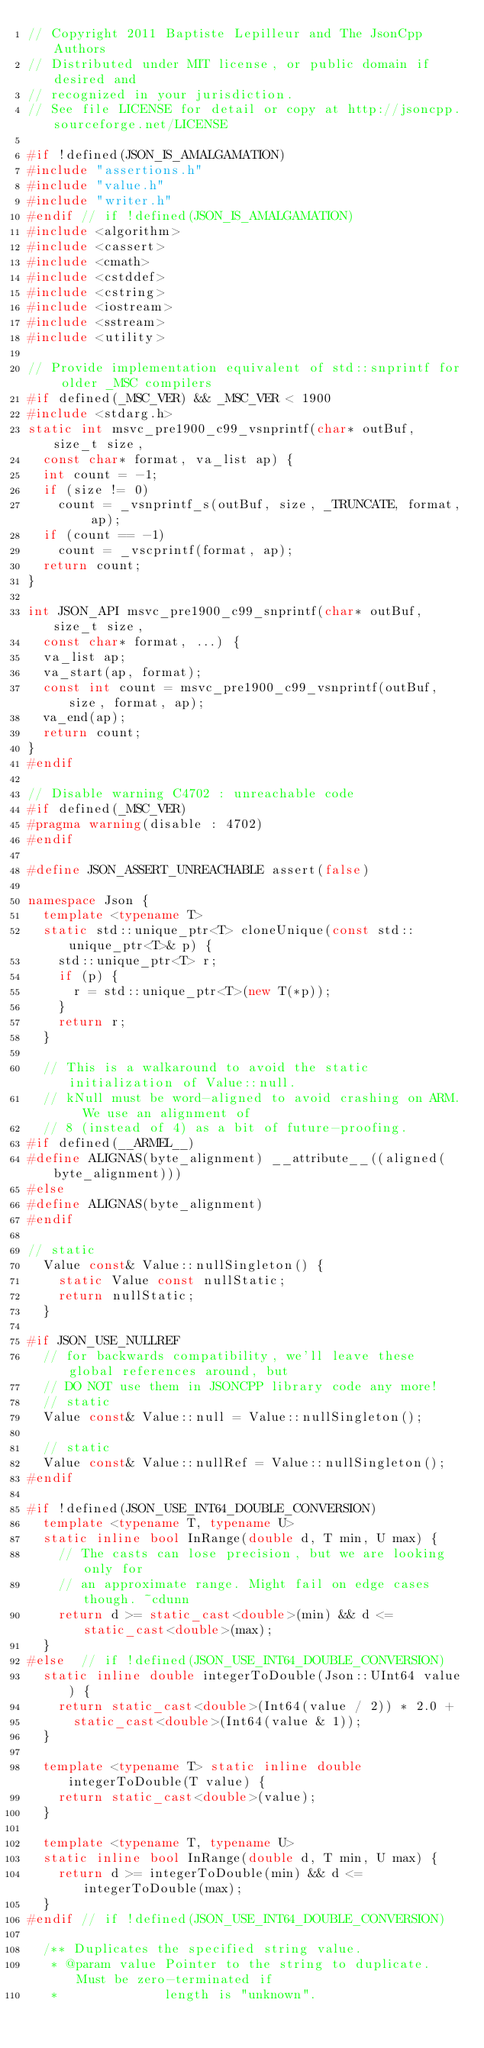Convert code to text. <code><loc_0><loc_0><loc_500><loc_500><_C++_>// Copyright 2011 Baptiste Lepilleur and The JsonCpp Authors
// Distributed under MIT license, or public domain if desired and
// recognized in your jurisdiction.
// See file LICENSE for detail or copy at http://jsoncpp.sourceforge.net/LICENSE

#if !defined(JSON_IS_AMALGAMATION)
#include "assertions.h"
#include "value.h"
#include "writer.h"
#endif // if !defined(JSON_IS_AMALGAMATION)
#include <algorithm>
#include <cassert>
#include <cmath>
#include <cstddef>
#include <cstring>
#include <iostream>
#include <sstream>
#include <utility>

// Provide implementation equivalent of std::snprintf for older _MSC compilers
#if defined(_MSC_VER) && _MSC_VER < 1900
#include <stdarg.h>
static int msvc_pre1900_c99_vsnprintf(char* outBuf, size_t size,
	const char* format, va_list ap) {
	int count = -1;
	if (size != 0)
		count = _vsnprintf_s(outBuf, size, _TRUNCATE, format, ap);
	if (count == -1)
		count = _vscprintf(format, ap);
	return count;
}

int JSON_API msvc_pre1900_c99_snprintf(char* outBuf, size_t size,
	const char* format, ...) {
	va_list ap;
	va_start(ap, format);
	const int count = msvc_pre1900_c99_vsnprintf(outBuf, size, format, ap);
	va_end(ap);
	return count;
}
#endif

// Disable warning C4702 : unreachable code
#if defined(_MSC_VER)
#pragma warning(disable : 4702)
#endif

#define JSON_ASSERT_UNREACHABLE assert(false)

namespace Json {
	template <typename T>
	static std::unique_ptr<T> cloneUnique(const std::unique_ptr<T>& p) {
		std::unique_ptr<T> r;
		if (p) {
			r = std::unique_ptr<T>(new T(*p));
		}
		return r;
	}

	// This is a walkaround to avoid the static initialization of Value::null.
	// kNull must be word-aligned to avoid crashing on ARM.  We use an alignment of
	// 8 (instead of 4) as a bit of future-proofing.
#if defined(__ARMEL__)
#define ALIGNAS(byte_alignment) __attribute__((aligned(byte_alignment)))
#else
#define ALIGNAS(byte_alignment)
#endif

// static
	Value const& Value::nullSingleton() {
		static Value const nullStatic;
		return nullStatic;
	}

#if JSON_USE_NULLREF
	// for backwards compatibility, we'll leave these global references around, but
	// DO NOT use them in JSONCPP library code any more!
	// static
	Value const& Value::null = Value::nullSingleton();

	// static
	Value const& Value::nullRef = Value::nullSingleton();
#endif

#if !defined(JSON_USE_INT64_DOUBLE_CONVERSION)
	template <typename T, typename U>
	static inline bool InRange(double d, T min, U max) {
		// The casts can lose precision, but we are looking only for
		// an approximate range. Might fail on edge cases though. ~cdunn
		return d >= static_cast<double>(min) && d <= static_cast<double>(max);
	}
#else  // if !defined(JSON_USE_INT64_DOUBLE_CONVERSION)
	static inline double integerToDouble(Json::UInt64 value) {
		return static_cast<double>(Int64(value / 2)) * 2.0 +
			static_cast<double>(Int64(value & 1));
	}

	template <typename T> static inline double integerToDouble(T value) {
		return static_cast<double>(value);
	}

	template <typename T, typename U>
	static inline bool InRange(double d, T min, U max) {
		return d >= integerToDouble(min) && d <= integerToDouble(max);
	}
#endif // if !defined(JSON_USE_INT64_DOUBLE_CONVERSION)

	/** Duplicates the specified string value.
	 * @param value Pointer to the string to duplicate. Must be zero-terminated if
	 *              length is "unknown".</code> 